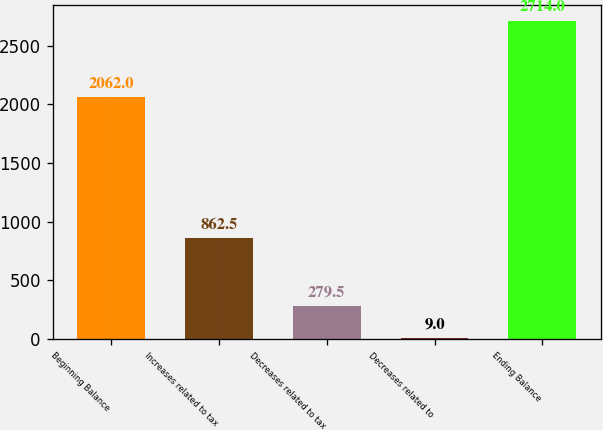Convert chart to OTSL. <chart><loc_0><loc_0><loc_500><loc_500><bar_chart><fcel>Beginning Balance<fcel>Increases related to tax<fcel>Decreases related to tax<fcel>Decreases related to<fcel>Ending Balance<nl><fcel>2062<fcel>862.5<fcel>279.5<fcel>9<fcel>2714<nl></chart> 